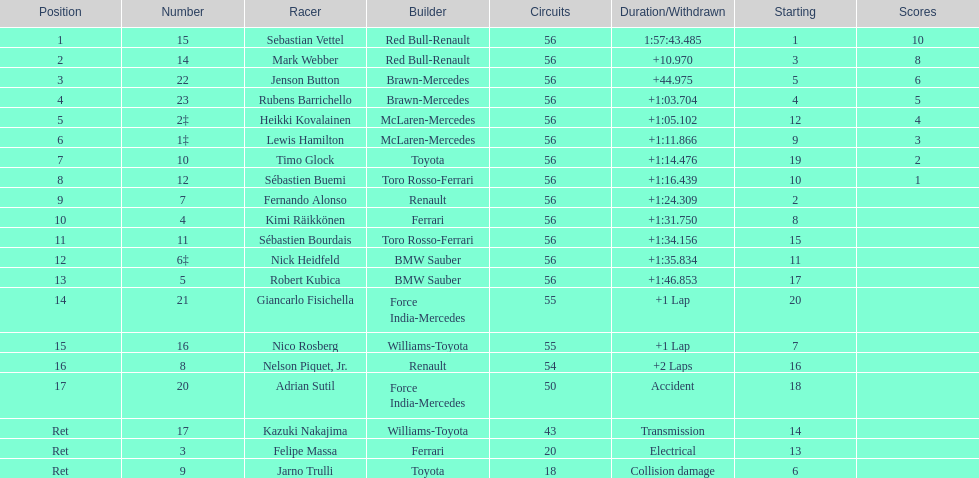Which driver's name is associated with a non-ferrari constructor? Sebastian Vettel. 